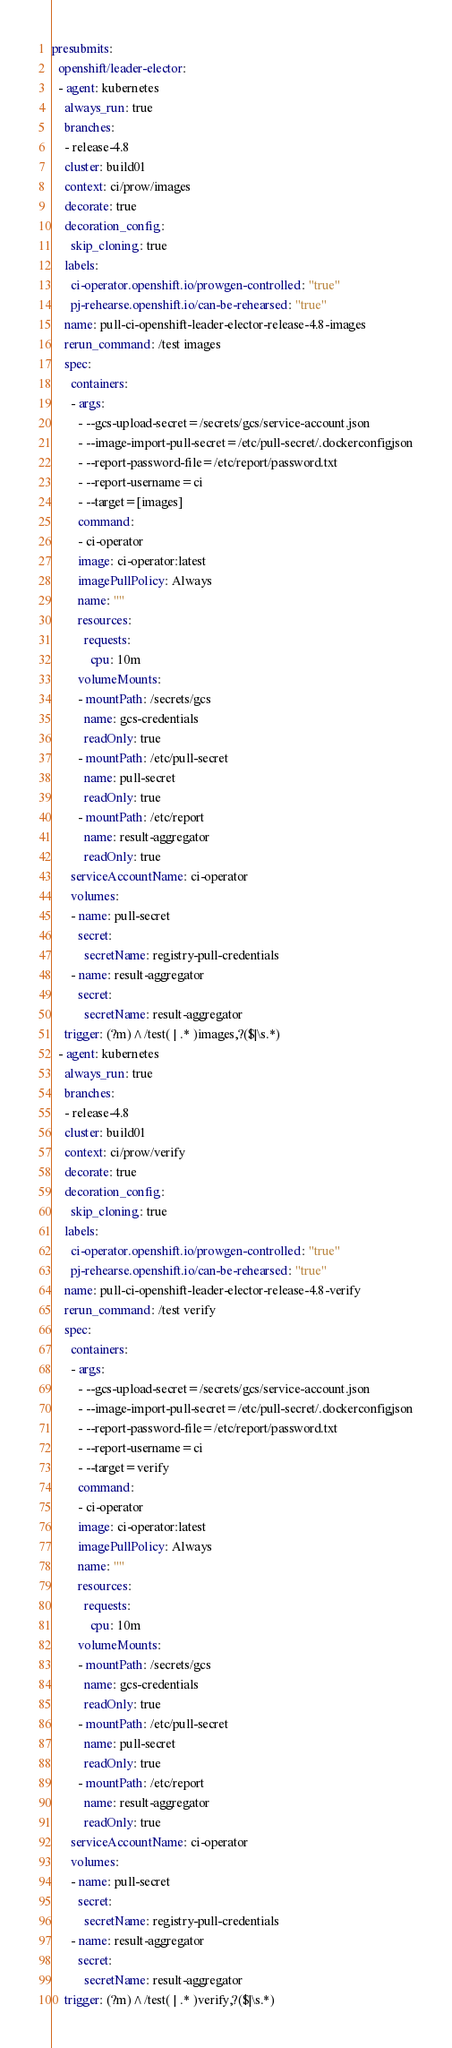<code> <loc_0><loc_0><loc_500><loc_500><_YAML_>presubmits:
  openshift/leader-elector:
  - agent: kubernetes
    always_run: true
    branches:
    - release-4.8
    cluster: build01
    context: ci/prow/images
    decorate: true
    decoration_config:
      skip_cloning: true
    labels:
      ci-operator.openshift.io/prowgen-controlled: "true"
      pj-rehearse.openshift.io/can-be-rehearsed: "true"
    name: pull-ci-openshift-leader-elector-release-4.8-images
    rerun_command: /test images
    spec:
      containers:
      - args:
        - --gcs-upload-secret=/secrets/gcs/service-account.json
        - --image-import-pull-secret=/etc/pull-secret/.dockerconfigjson
        - --report-password-file=/etc/report/password.txt
        - --report-username=ci
        - --target=[images]
        command:
        - ci-operator
        image: ci-operator:latest
        imagePullPolicy: Always
        name: ""
        resources:
          requests:
            cpu: 10m
        volumeMounts:
        - mountPath: /secrets/gcs
          name: gcs-credentials
          readOnly: true
        - mountPath: /etc/pull-secret
          name: pull-secret
          readOnly: true
        - mountPath: /etc/report
          name: result-aggregator
          readOnly: true
      serviceAccountName: ci-operator
      volumes:
      - name: pull-secret
        secret:
          secretName: registry-pull-credentials
      - name: result-aggregator
        secret:
          secretName: result-aggregator
    trigger: (?m)^/test( | .* )images,?($|\s.*)
  - agent: kubernetes
    always_run: true
    branches:
    - release-4.8
    cluster: build01
    context: ci/prow/verify
    decorate: true
    decoration_config:
      skip_cloning: true
    labels:
      ci-operator.openshift.io/prowgen-controlled: "true"
      pj-rehearse.openshift.io/can-be-rehearsed: "true"
    name: pull-ci-openshift-leader-elector-release-4.8-verify
    rerun_command: /test verify
    spec:
      containers:
      - args:
        - --gcs-upload-secret=/secrets/gcs/service-account.json
        - --image-import-pull-secret=/etc/pull-secret/.dockerconfigjson
        - --report-password-file=/etc/report/password.txt
        - --report-username=ci
        - --target=verify
        command:
        - ci-operator
        image: ci-operator:latest
        imagePullPolicy: Always
        name: ""
        resources:
          requests:
            cpu: 10m
        volumeMounts:
        - mountPath: /secrets/gcs
          name: gcs-credentials
          readOnly: true
        - mountPath: /etc/pull-secret
          name: pull-secret
          readOnly: true
        - mountPath: /etc/report
          name: result-aggregator
          readOnly: true
      serviceAccountName: ci-operator
      volumes:
      - name: pull-secret
        secret:
          secretName: registry-pull-credentials
      - name: result-aggregator
        secret:
          secretName: result-aggregator
    trigger: (?m)^/test( | .* )verify,?($|\s.*)
</code> 